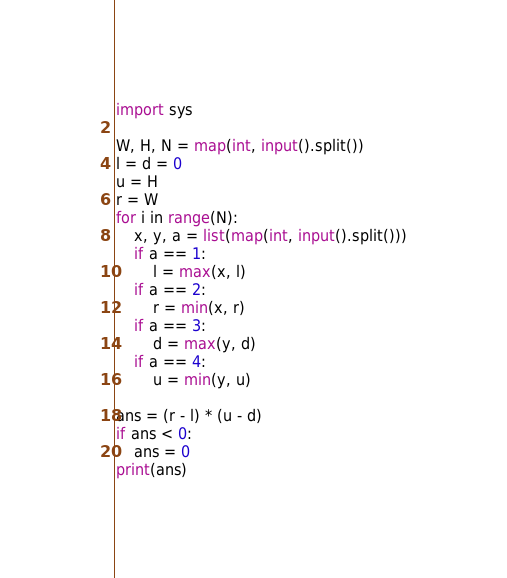Convert code to text. <code><loc_0><loc_0><loc_500><loc_500><_Python_>import sys

W, H, N = map(int, input().split())
l = d = 0
u = H
r = W
for i in range(N):
    x, y, a = list(map(int, input().split()))
    if a == 1:
        l = max(x, l)
    if a == 2:
        r = min(x, r)
    if a == 3:
        d = max(y, d)
    if a == 4:
        u = min(y, u)

ans = (r - l) * (u - d)
if ans < 0:
    ans = 0
print(ans)
</code> 